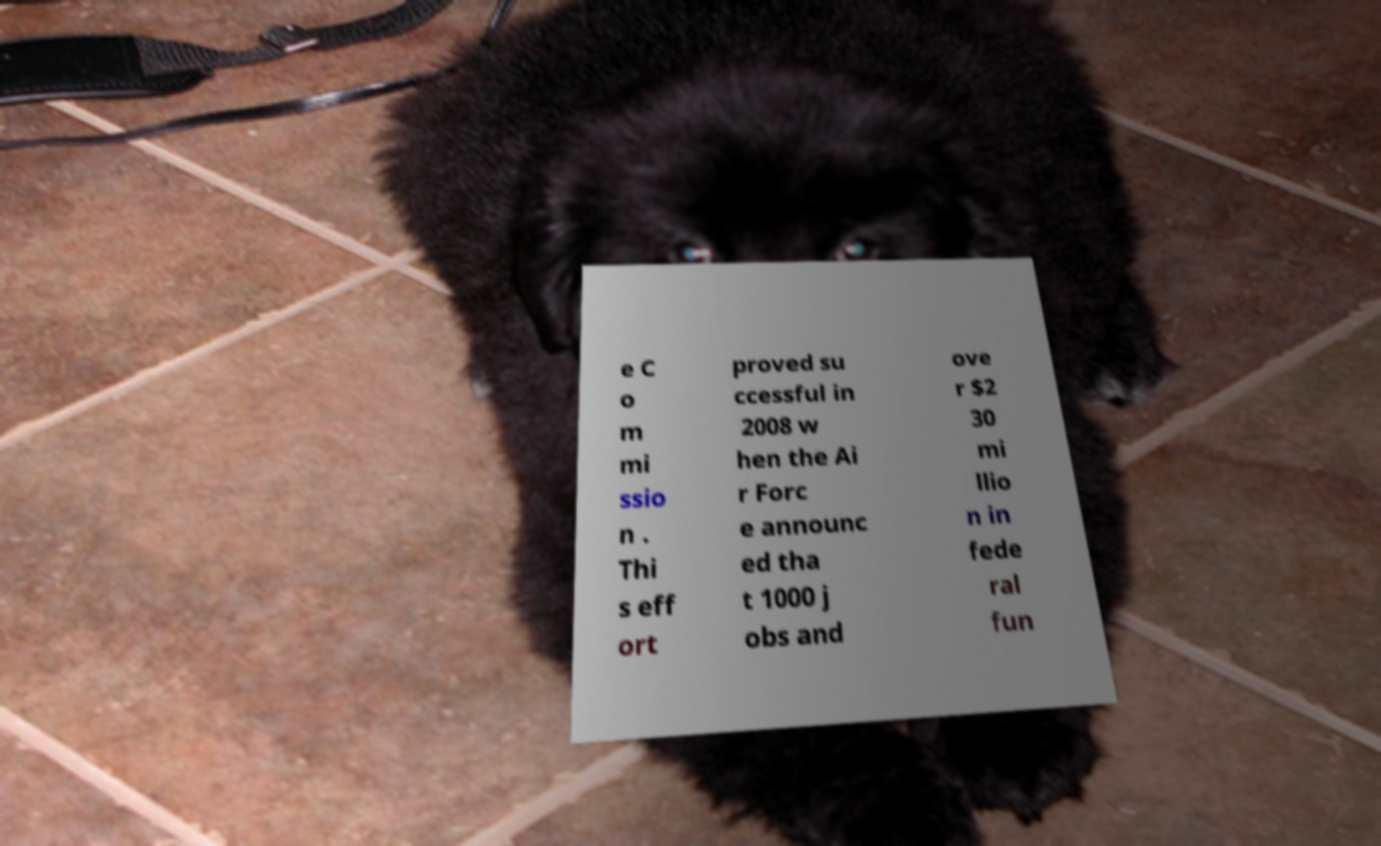For documentation purposes, I need the text within this image transcribed. Could you provide that? e C o m mi ssio n . Thi s eff ort proved su ccessful in 2008 w hen the Ai r Forc e announc ed tha t 1000 j obs and ove r $2 30 mi llio n in fede ral fun 